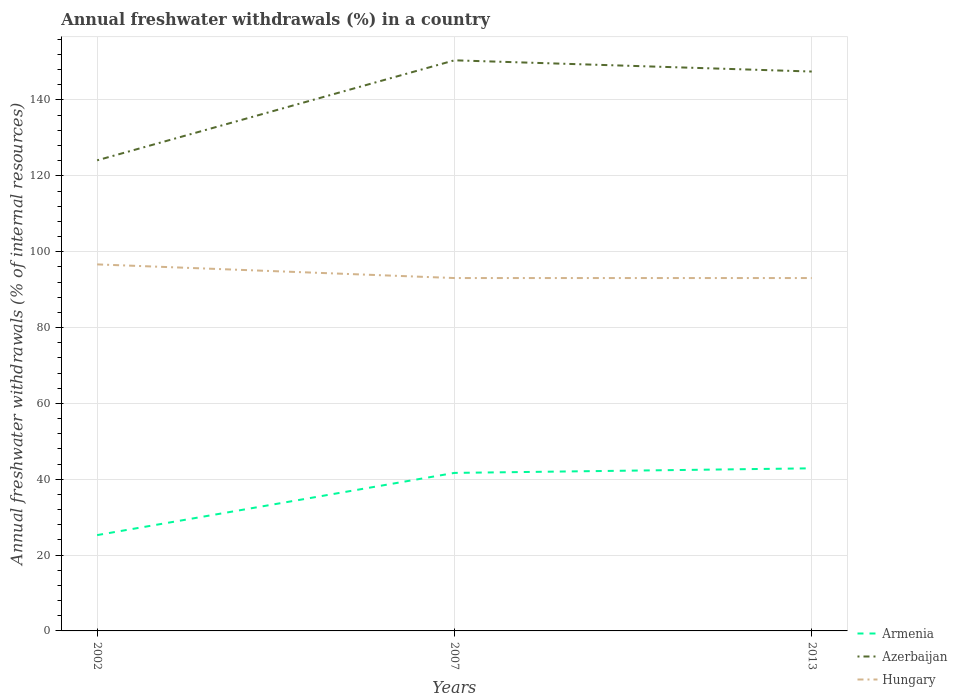Is the number of lines equal to the number of legend labels?
Give a very brief answer. Yes. Across all years, what is the maximum percentage of annual freshwater withdrawals in Armenia?
Provide a succinct answer. 25.27. In which year was the percentage of annual freshwater withdrawals in Armenia maximum?
Provide a short and direct response. 2002. What is the total percentage of annual freshwater withdrawals in Azerbaijan in the graph?
Your answer should be compact. -26.37. What is the difference between the highest and the second highest percentage of annual freshwater withdrawals in Armenia?
Offer a terse response. 17.61. Is the percentage of annual freshwater withdrawals in Armenia strictly greater than the percentage of annual freshwater withdrawals in Azerbaijan over the years?
Make the answer very short. Yes. How many lines are there?
Offer a very short reply. 3. How many years are there in the graph?
Your answer should be compact. 3. What is the difference between two consecutive major ticks on the Y-axis?
Give a very brief answer. 20. Are the values on the major ticks of Y-axis written in scientific E-notation?
Offer a terse response. No. Does the graph contain grids?
Make the answer very short. Yes. How many legend labels are there?
Offer a terse response. 3. How are the legend labels stacked?
Ensure brevity in your answer.  Vertical. What is the title of the graph?
Your response must be concise. Annual freshwater withdrawals (%) in a country. What is the label or title of the Y-axis?
Ensure brevity in your answer.  Annual freshwater withdrawals (% of internal resources). What is the Annual freshwater withdrawals (% of internal resources) in Armenia in 2002?
Your answer should be very brief. 25.27. What is the Annual freshwater withdrawals (% of internal resources) of Azerbaijan in 2002?
Offer a terse response. 124.09. What is the Annual freshwater withdrawals (% of internal resources) in Hungary in 2002?
Provide a short and direct response. 96.65. What is the Annual freshwater withdrawals (% of internal resources) in Armenia in 2007?
Keep it short and to the point. 41.67. What is the Annual freshwater withdrawals (% of internal resources) in Azerbaijan in 2007?
Keep it short and to the point. 150.46. What is the Annual freshwater withdrawals (% of internal resources) of Hungary in 2007?
Offer a very short reply. 93.05. What is the Annual freshwater withdrawals (% of internal resources) in Armenia in 2013?
Offer a terse response. 42.88. What is the Annual freshwater withdrawals (% of internal resources) in Azerbaijan in 2013?
Provide a succinct answer. 147.5. What is the Annual freshwater withdrawals (% of internal resources) of Hungary in 2013?
Provide a short and direct response. 93.05. Across all years, what is the maximum Annual freshwater withdrawals (% of internal resources) of Armenia?
Ensure brevity in your answer.  42.88. Across all years, what is the maximum Annual freshwater withdrawals (% of internal resources) in Azerbaijan?
Your answer should be very brief. 150.46. Across all years, what is the maximum Annual freshwater withdrawals (% of internal resources) of Hungary?
Ensure brevity in your answer.  96.65. Across all years, what is the minimum Annual freshwater withdrawals (% of internal resources) of Armenia?
Your answer should be very brief. 25.27. Across all years, what is the minimum Annual freshwater withdrawals (% of internal resources) of Azerbaijan?
Your response must be concise. 124.09. Across all years, what is the minimum Annual freshwater withdrawals (% of internal resources) of Hungary?
Make the answer very short. 93.05. What is the total Annual freshwater withdrawals (% of internal resources) of Armenia in the graph?
Offer a terse response. 109.81. What is the total Annual freshwater withdrawals (% of internal resources) in Azerbaijan in the graph?
Your answer should be very brief. 422.06. What is the total Annual freshwater withdrawals (% of internal resources) of Hungary in the graph?
Provide a succinct answer. 282.75. What is the difference between the Annual freshwater withdrawals (% of internal resources) of Armenia in 2002 and that in 2007?
Your answer should be very brief. -16.4. What is the difference between the Annual freshwater withdrawals (% of internal resources) of Azerbaijan in 2002 and that in 2007?
Keep it short and to the point. -26.37. What is the difference between the Annual freshwater withdrawals (% of internal resources) in Armenia in 2002 and that in 2013?
Make the answer very short. -17.61. What is the difference between the Annual freshwater withdrawals (% of internal resources) of Azerbaijan in 2002 and that in 2013?
Provide a short and direct response. -23.41. What is the difference between the Annual freshwater withdrawals (% of internal resources) of Hungary in 2002 and that in 2013?
Your response must be concise. 3.6. What is the difference between the Annual freshwater withdrawals (% of internal resources) of Armenia in 2007 and that in 2013?
Ensure brevity in your answer.  -1.21. What is the difference between the Annual freshwater withdrawals (% of internal resources) in Azerbaijan in 2007 and that in 2013?
Keep it short and to the point. 2.96. What is the difference between the Annual freshwater withdrawals (% of internal resources) in Armenia in 2002 and the Annual freshwater withdrawals (% of internal resources) in Azerbaijan in 2007?
Give a very brief answer. -125.2. What is the difference between the Annual freshwater withdrawals (% of internal resources) in Armenia in 2002 and the Annual freshwater withdrawals (% of internal resources) in Hungary in 2007?
Keep it short and to the point. -67.78. What is the difference between the Annual freshwater withdrawals (% of internal resources) in Azerbaijan in 2002 and the Annual freshwater withdrawals (% of internal resources) in Hungary in 2007?
Provide a succinct answer. 31.04. What is the difference between the Annual freshwater withdrawals (% of internal resources) of Armenia in 2002 and the Annual freshwater withdrawals (% of internal resources) of Azerbaijan in 2013?
Keep it short and to the point. -122.24. What is the difference between the Annual freshwater withdrawals (% of internal resources) of Armenia in 2002 and the Annual freshwater withdrawals (% of internal resources) of Hungary in 2013?
Your answer should be compact. -67.78. What is the difference between the Annual freshwater withdrawals (% of internal resources) in Azerbaijan in 2002 and the Annual freshwater withdrawals (% of internal resources) in Hungary in 2013?
Offer a terse response. 31.04. What is the difference between the Annual freshwater withdrawals (% of internal resources) in Armenia in 2007 and the Annual freshwater withdrawals (% of internal resources) in Azerbaijan in 2013?
Make the answer very short. -105.84. What is the difference between the Annual freshwater withdrawals (% of internal resources) of Armenia in 2007 and the Annual freshwater withdrawals (% of internal resources) of Hungary in 2013?
Offer a very short reply. -51.38. What is the difference between the Annual freshwater withdrawals (% of internal resources) in Azerbaijan in 2007 and the Annual freshwater withdrawals (% of internal resources) in Hungary in 2013?
Your answer should be very brief. 57.41. What is the average Annual freshwater withdrawals (% of internal resources) in Armenia per year?
Keep it short and to the point. 36.6. What is the average Annual freshwater withdrawals (% of internal resources) in Azerbaijan per year?
Offer a very short reply. 140.69. What is the average Annual freshwater withdrawals (% of internal resources) in Hungary per year?
Your response must be concise. 94.25. In the year 2002, what is the difference between the Annual freshwater withdrawals (% of internal resources) in Armenia and Annual freshwater withdrawals (% of internal resources) in Azerbaijan?
Your response must be concise. -98.83. In the year 2002, what is the difference between the Annual freshwater withdrawals (% of internal resources) in Armenia and Annual freshwater withdrawals (% of internal resources) in Hungary?
Your answer should be very brief. -71.38. In the year 2002, what is the difference between the Annual freshwater withdrawals (% of internal resources) of Azerbaijan and Annual freshwater withdrawals (% of internal resources) of Hungary?
Provide a short and direct response. 27.44. In the year 2007, what is the difference between the Annual freshwater withdrawals (% of internal resources) of Armenia and Annual freshwater withdrawals (% of internal resources) of Azerbaijan?
Your answer should be very brief. -108.79. In the year 2007, what is the difference between the Annual freshwater withdrawals (% of internal resources) in Armenia and Annual freshwater withdrawals (% of internal resources) in Hungary?
Make the answer very short. -51.38. In the year 2007, what is the difference between the Annual freshwater withdrawals (% of internal resources) in Azerbaijan and Annual freshwater withdrawals (% of internal resources) in Hungary?
Ensure brevity in your answer.  57.41. In the year 2013, what is the difference between the Annual freshwater withdrawals (% of internal resources) in Armenia and Annual freshwater withdrawals (% of internal resources) in Azerbaijan?
Make the answer very short. -104.63. In the year 2013, what is the difference between the Annual freshwater withdrawals (% of internal resources) of Armenia and Annual freshwater withdrawals (% of internal resources) of Hungary?
Your answer should be very brief. -50.17. In the year 2013, what is the difference between the Annual freshwater withdrawals (% of internal resources) of Azerbaijan and Annual freshwater withdrawals (% of internal resources) of Hungary?
Ensure brevity in your answer.  54.45. What is the ratio of the Annual freshwater withdrawals (% of internal resources) of Armenia in 2002 to that in 2007?
Provide a succinct answer. 0.61. What is the ratio of the Annual freshwater withdrawals (% of internal resources) in Azerbaijan in 2002 to that in 2007?
Offer a very short reply. 0.82. What is the ratio of the Annual freshwater withdrawals (% of internal resources) in Hungary in 2002 to that in 2007?
Provide a short and direct response. 1.04. What is the ratio of the Annual freshwater withdrawals (% of internal resources) of Armenia in 2002 to that in 2013?
Ensure brevity in your answer.  0.59. What is the ratio of the Annual freshwater withdrawals (% of internal resources) in Azerbaijan in 2002 to that in 2013?
Your response must be concise. 0.84. What is the ratio of the Annual freshwater withdrawals (% of internal resources) of Hungary in 2002 to that in 2013?
Give a very brief answer. 1.04. What is the ratio of the Annual freshwater withdrawals (% of internal resources) in Armenia in 2007 to that in 2013?
Offer a terse response. 0.97. What is the ratio of the Annual freshwater withdrawals (% of internal resources) in Azerbaijan in 2007 to that in 2013?
Provide a short and direct response. 1.02. What is the difference between the highest and the second highest Annual freshwater withdrawals (% of internal resources) in Armenia?
Keep it short and to the point. 1.21. What is the difference between the highest and the second highest Annual freshwater withdrawals (% of internal resources) of Azerbaijan?
Ensure brevity in your answer.  2.96. What is the difference between the highest and the lowest Annual freshwater withdrawals (% of internal resources) in Armenia?
Give a very brief answer. 17.61. What is the difference between the highest and the lowest Annual freshwater withdrawals (% of internal resources) of Azerbaijan?
Give a very brief answer. 26.37. What is the difference between the highest and the lowest Annual freshwater withdrawals (% of internal resources) in Hungary?
Offer a terse response. 3.6. 